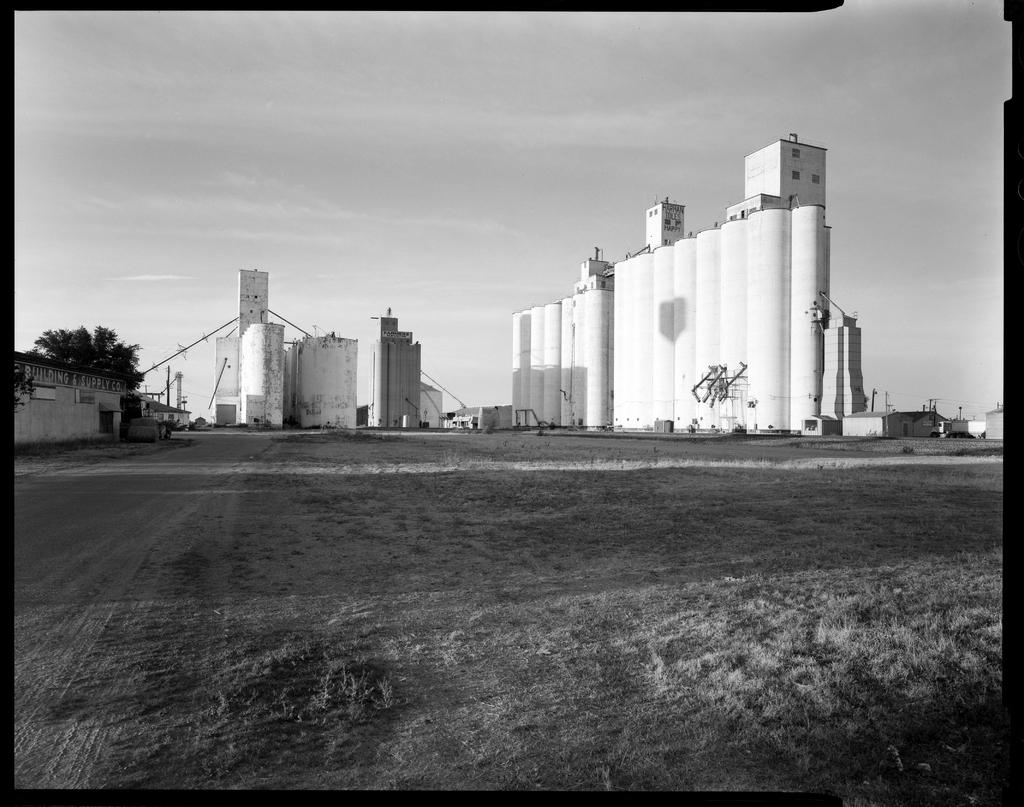What is the main feature of the image? There is a lot of empty land in the image. What can be seen in the background of the image? There are industries visible in the background of the image. Where is the tree located in the image? There is a tree on the left side of the image. What position does the tank hold in the image? There is no tank present in the image. 